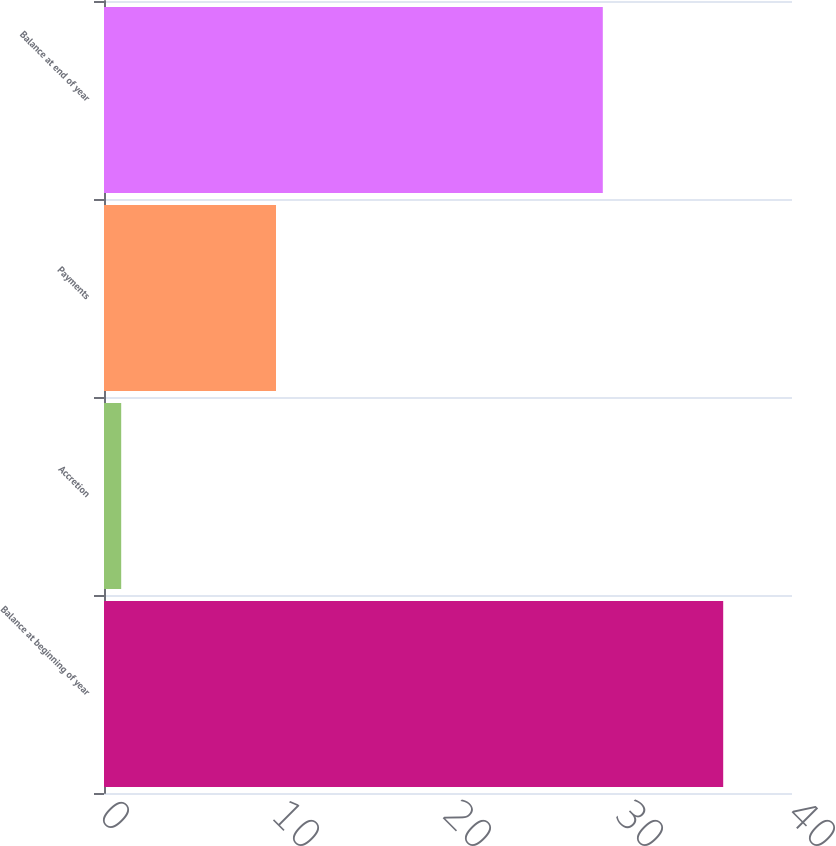Convert chart. <chart><loc_0><loc_0><loc_500><loc_500><bar_chart><fcel>Balance at beginning of year<fcel>Accretion<fcel>Payments<fcel>Balance at end of year<nl><fcel>36<fcel>1<fcel>10<fcel>29<nl></chart> 